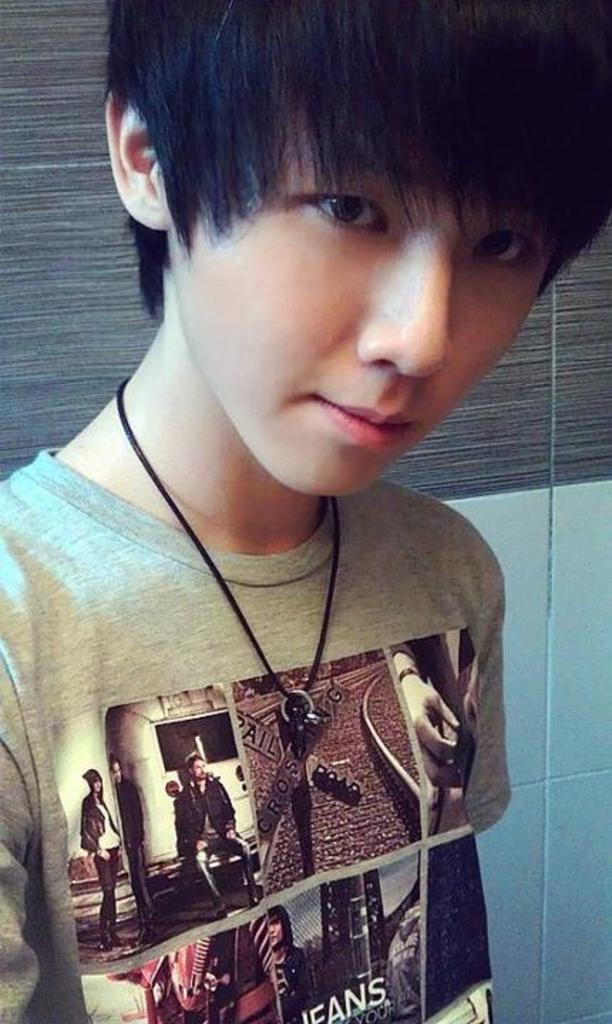Who is present in the image? There is a man in the image. What is the man's position in relation to the wall? The man is standing in front of a wall. What is the man wearing? The man is wearing a grey color t-shirt. What accessory is the man wearing around his neck? The man has a locket around his neck. What type of stocking is the man wearing in the image? There is no mention of stockings in the image, so it cannot be determined if the man is wearing any. 